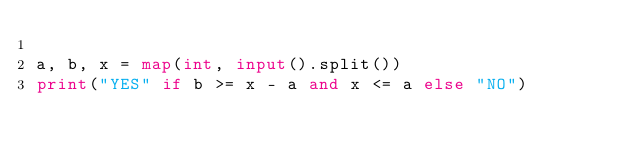<code> <loc_0><loc_0><loc_500><loc_500><_Python_>
a, b, x = map(int, input().split())
print("YES" if b >= x - a and x <= a else "NO")</code> 